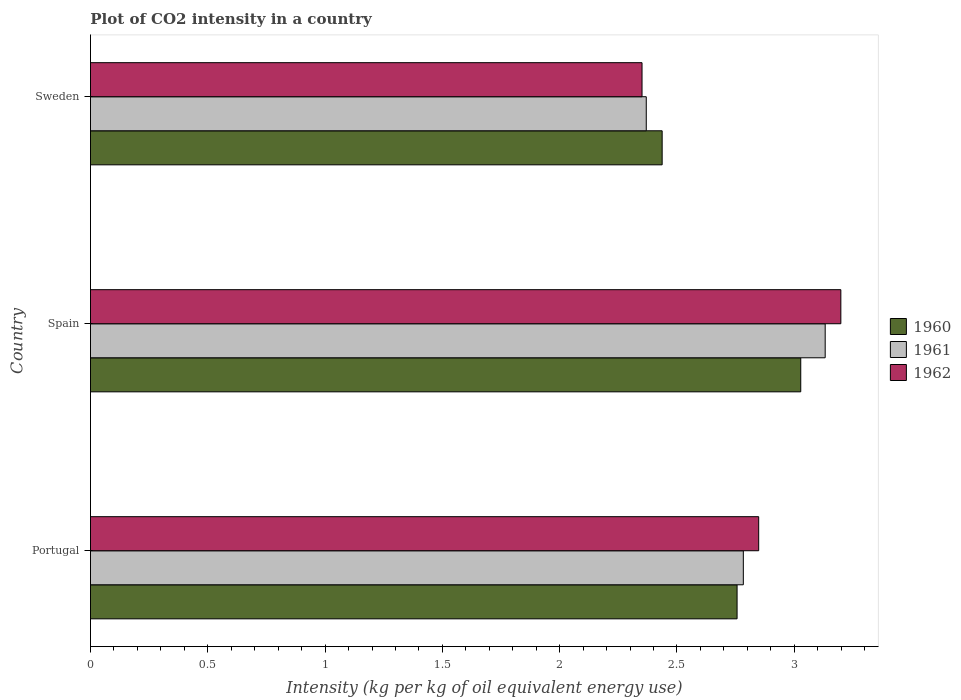How many different coloured bars are there?
Provide a short and direct response. 3. Are the number of bars per tick equal to the number of legend labels?
Your answer should be very brief. Yes. What is the CO2 intensity in in 1962 in Sweden?
Give a very brief answer. 2.35. Across all countries, what is the maximum CO2 intensity in in 1961?
Provide a succinct answer. 3.13. Across all countries, what is the minimum CO2 intensity in in 1960?
Offer a very short reply. 2.44. In which country was the CO2 intensity in in 1962 maximum?
Your answer should be very brief. Spain. What is the total CO2 intensity in in 1962 in the graph?
Make the answer very short. 8.4. What is the difference between the CO2 intensity in in 1960 in Portugal and that in Sweden?
Your response must be concise. 0.32. What is the difference between the CO2 intensity in in 1961 in Sweden and the CO2 intensity in in 1960 in Portugal?
Keep it short and to the point. -0.39. What is the average CO2 intensity in in 1962 per country?
Provide a short and direct response. 2.8. What is the difference between the CO2 intensity in in 1961 and CO2 intensity in in 1960 in Sweden?
Keep it short and to the point. -0.07. In how many countries, is the CO2 intensity in in 1962 greater than 2.5 kg?
Offer a very short reply. 2. What is the ratio of the CO2 intensity in in 1962 in Portugal to that in Sweden?
Your answer should be compact. 1.21. Is the difference between the CO2 intensity in in 1961 in Spain and Sweden greater than the difference between the CO2 intensity in in 1960 in Spain and Sweden?
Provide a short and direct response. Yes. What is the difference between the highest and the second highest CO2 intensity in in 1962?
Ensure brevity in your answer.  0.35. What is the difference between the highest and the lowest CO2 intensity in in 1962?
Give a very brief answer. 0.85. Is the sum of the CO2 intensity in in 1960 in Portugal and Spain greater than the maximum CO2 intensity in in 1962 across all countries?
Offer a very short reply. Yes. What does the 1st bar from the top in Sweden represents?
Your answer should be very brief. 1962. Does the graph contain any zero values?
Provide a succinct answer. No. How many legend labels are there?
Your answer should be very brief. 3. What is the title of the graph?
Offer a terse response. Plot of CO2 intensity in a country. Does "1968" appear as one of the legend labels in the graph?
Your answer should be very brief. No. What is the label or title of the X-axis?
Provide a succinct answer. Intensity (kg per kg of oil equivalent energy use). What is the label or title of the Y-axis?
Provide a succinct answer. Country. What is the Intensity (kg per kg of oil equivalent energy use) in 1960 in Portugal?
Provide a succinct answer. 2.76. What is the Intensity (kg per kg of oil equivalent energy use) of 1961 in Portugal?
Provide a succinct answer. 2.78. What is the Intensity (kg per kg of oil equivalent energy use) in 1962 in Portugal?
Ensure brevity in your answer.  2.85. What is the Intensity (kg per kg of oil equivalent energy use) in 1960 in Spain?
Give a very brief answer. 3.03. What is the Intensity (kg per kg of oil equivalent energy use) of 1961 in Spain?
Make the answer very short. 3.13. What is the Intensity (kg per kg of oil equivalent energy use) in 1962 in Spain?
Provide a succinct answer. 3.2. What is the Intensity (kg per kg of oil equivalent energy use) of 1960 in Sweden?
Keep it short and to the point. 2.44. What is the Intensity (kg per kg of oil equivalent energy use) of 1961 in Sweden?
Your answer should be compact. 2.37. What is the Intensity (kg per kg of oil equivalent energy use) in 1962 in Sweden?
Offer a very short reply. 2.35. Across all countries, what is the maximum Intensity (kg per kg of oil equivalent energy use) of 1960?
Your answer should be compact. 3.03. Across all countries, what is the maximum Intensity (kg per kg of oil equivalent energy use) in 1961?
Your answer should be very brief. 3.13. Across all countries, what is the maximum Intensity (kg per kg of oil equivalent energy use) in 1962?
Provide a succinct answer. 3.2. Across all countries, what is the minimum Intensity (kg per kg of oil equivalent energy use) in 1960?
Your response must be concise. 2.44. Across all countries, what is the minimum Intensity (kg per kg of oil equivalent energy use) in 1961?
Keep it short and to the point. 2.37. Across all countries, what is the minimum Intensity (kg per kg of oil equivalent energy use) in 1962?
Offer a very short reply. 2.35. What is the total Intensity (kg per kg of oil equivalent energy use) in 1960 in the graph?
Give a very brief answer. 8.22. What is the total Intensity (kg per kg of oil equivalent energy use) of 1961 in the graph?
Your response must be concise. 8.28. What is the total Intensity (kg per kg of oil equivalent energy use) in 1962 in the graph?
Make the answer very short. 8.4. What is the difference between the Intensity (kg per kg of oil equivalent energy use) in 1960 in Portugal and that in Spain?
Give a very brief answer. -0.27. What is the difference between the Intensity (kg per kg of oil equivalent energy use) in 1961 in Portugal and that in Spain?
Offer a terse response. -0.35. What is the difference between the Intensity (kg per kg of oil equivalent energy use) in 1962 in Portugal and that in Spain?
Keep it short and to the point. -0.35. What is the difference between the Intensity (kg per kg of oil equivalent energy use) of 1960 in Portugal and that in Sweden?
Keep it short and to the point. 0.32. What is the difference between the Intensity (kg per kg of oil equivalent energy use) in 1961 in Portugal and that in Sweden?
Provide a short and direct response. 0.41. What is the difference between the Intensity (kg per kg of oil equivalent energy use) of 1962 in Portugal and that in Sweden?
Provide a succinct answer. 0.5. What is the difference between the Intensity (kg per kg of oil equivalent energy use) in 1960 in Spain and that in Sweden?
Your answer should be compact. 0.59. What is the difference between the Intensity (kg per kg of oil equivalent energy use) of 1961 in Spain and that in Sweden?
Your response must be concise. 0.76. What is the difference between the Intensity (kg per kg of oil equivalent energy use) of 1962 in Spain and that in Sweden?
Give a very brief answer. 0.85. What is the difference between the Intensity (kg per kg of oil equivalent energy use) of 1960 in Portugal and the Intensity (kg per kg of oil equivalent energy use) of 1961 in Spain?
Offer a very short reply. -0.38. What is the difference between the Intensity (kg per kg of oil equivalent energy use) in 1960 in Portugal and the Intensity (kg per kg of oil equivalent energy use) in 1962 in Spain?
Your answer should be compact. -0.44. What is the difference between the Intensity (kg per kg of oil equivalent energy use) of 1961 in Portugal and the Intensity (kg per kg of oil equivalent energy use) of 1962 in Spain?
Make the answer very short. -0.42. What is the difference between the Intensity (kg per kg of oil equivalent energy use) of 1960 in Portugal and the Intensity (kg per kg of oil equivalent energy use) of 1961 in Sweden?
Your response must be concise. 0.39. What is the difference between the Intensity (kg per kg of oil equivalent energy use) in 1960 in Portugal and the Intensity (kg per kg of oil equivalent energy use) in 1962 in Sweden?
Your response must be concise. 0.41. What is the difference between the Intensity (kg per kg of oil equivalent energy use) in 1961 in Portugal and the Intensity (kg per kg of oil equivalent energy use) in 1962 in Sweden?
Make the answer very short. 0.43. What is the difference between the Intensity (kg per kg of oil equivalent energy use) in 1960 in Spain and the Intensity (kg per kg of oil equivalent energy use) in 1961 in Sweden?
Your answer should be compact. 0.66. What is the difference between the Intensity (kg per kg of oil equivalent energy use) of 1960 in Spain and the Intensity (kg per kg of oil equivalent energy use) of 1962 in Sweden?
Offer a very short reply. 0.68. What is the difference between the Intensity (kg per kg of oil equivalent energy use) of 1961 in Spain and the Intensity (kg per kg of oil equivalent energy use) of 1962 in Sweden?
Offer a terse response. 0.78. What is the average Intensity (kg per kg of oil equivalent energy use) of 1960 per country?
Provide a short and direct response. 2.74. What is the average Intensity (kg per kg of oil equivalent energy use) of 1961 per country?
Ensure brevity in your answer.  2.76. What is the average Intensity (kg per kg of oil equivalent energy use) in 1962 per country?
Your answer should be compact. 2.8. What is the difference between the Intensity (kg per kg of oil equivalent energy use) of 1960 and Intensity (kg per kg of oil equivalent energy use) of 1961 in Portugal?
Give a very brief answer. -0.03. What is the difference between the Intensity (kg per kg of oil equivalent energy use) of 1960 and Intensity (kg per kg of oil equivalent energy use) of 1962 in Portugal?
Give a very brief answer. -0.09. What is the difference between the Intensity (kg per kg of oil equivalent energy use) of 1961 and Intensity (kg per kg of oil equivalent energy use) of 1962 in Portugal?
Ensure brevity in your answer.  -0.07. What is the difference between the Intensity (kg per kg of oil equivalent energy use) in 1960 and Intensity (kg per kg of oil equivalent energy use) in 1961 in Spain?
Offer a very short reply. -0.1. What is the difference between the Intensity (kg per kg of oil equivalent energy use) of 1960 and Intensity (kg per kg of oil equivalent energy use) of 1962 in Spain?
Provide a succinct answer. -0.17. What is the difference between the Intensity (kg per kg of oil equivalent energy use) of 1961 and Intensity (kg per kg of oil equivalent energy use) of 1962 in Spain?
Your answer should be compact. -0.07. What is the difference between the Intensity (kg per kg of oil equivalent energy use) in 1960 and Intensity (kg per kg of oil equivalent energy use) in 1961 in Sweden?
Make the answer very short. 0.07. What is the difference between the Intensity (kg per kg of oil equivalent energy use) in 1960 and Intensity (kg per kg of oil equivalent energy use) in 1962 in Sweden?
Give a very brief answer. 0.09. What is the difference between the Intensity (kg per kg of oil equivalent energy use) of 1961 and Intensity (kg per kg of oil equivalent energy use) of 1962 in Sweden?
Your response must be concise. 0.02. What is the ratio of the Intensity (kg per kg of oil equivalent energy use) in 1960 in Portugal to that in Spain?
Make the answer very short. 0.91. What is the ratio of the Intensity (kg per kg of oil equivalent energy use) in 1961 in Portugal to that in Spain?
Your answer should be very brief. 0.89. What is the ratio of the Intensity (kg per kg of oil equivalent energy use) in 1962 in Portugal to that in Spain?
Offer a very short reply. 0.89. What is the ratio of the Intensity (kg per kg of oil equivalent energy use) in 1960 in Portugal to that in Sweden?
Keep it short and to the point. 1.13. What is the ratio of the Intensity (kg per kg of oil equivalent energy use) in 1961 in Portugal to that in Sweden?
Give a very brief answer. 1.17. What is the ratio of the Intensity (kg per kg of oil equivalent energy use) of 1962 in Portugal to that in Sweden?
Your response must be concise. 1.21. What is the ratio of the Intensity (kg per kg of oil equivalent energy use) in 1960 in Spain to that in Sweden?
Make the answer very short. 1.24. What is the ratio of the Intensity (kg per kg of oil equivalent energy use) of 1961 in Spain to that in Sweden?
Provide a succinct answer. 1.32. What is the ratio of the Intensity (kg per kg of oil equivalent energy use) of 1962 in Spain to that in Sweden?
Your response must be concise. 1.36. What is the difference between the highest and the second highest Intensity (kg per kg of oil equivalent energy use) of 1960?
Make the answer very short. 0.27. What is the difference between the highest and the second highest Intensity (kg per kg of oil equivalent energy use) in 1961?
Offer a very short reply. 0.35. What is the difference between the highest and the second highest Intensity (kg per kg of oil equivalent energy use) of 1962?
Provide a short and direct response. 0.35. What is the difference between the highest and the lowest Intensity (kg per kg of oil equivalent energy use) in 1960?
Your answer should be very brief. 0.59. What is the difference between the highest and the lowest Intensity (kg per kg of oil equivalent energy use) in 1961?
Your answer should be compact. 0.76. What is the difference between the highest and the lowest Intensity (kg per kg of oil equivalent energy use) in 1962?
Provide a succinct answer. 0.85. 